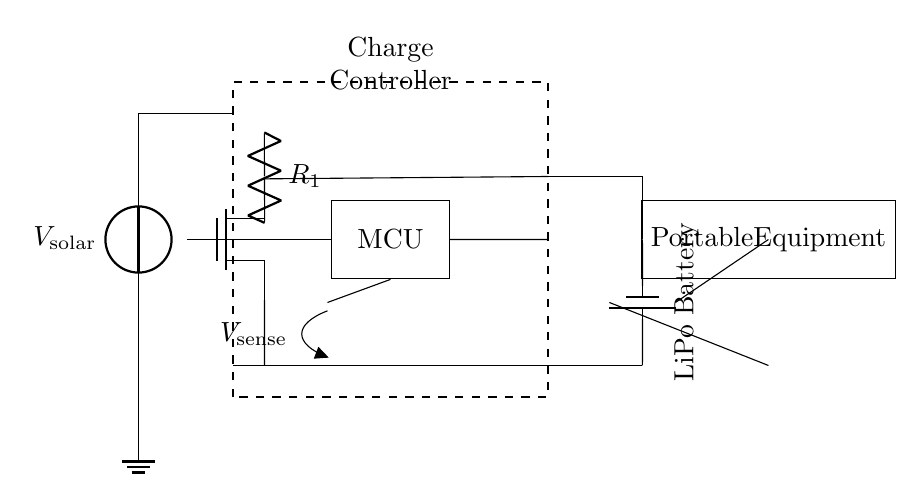What is the main purpose of the charge controller in this circuit? The charge controller regulates the voltage and current from the solar panel to the battery to prevent overcharging and ensure safe operation.
Answer: regulates voltage and current What type of battery is used in this circuit? The battery is a LiPo battery, indicated by the labeling next to the battery symbol in the circuit diagram.
Answer: LiPo Battery How many components are connected in series to the load? There are two components (the battery and load) connected in series; they share the same current path from the battery to the load.
Answer: Two What is the function of the resistor labeled R1? The resistor R1 is used to limit current to the gate of the MOSFET, thereby controlling its switching operation based on the signal from the microcontroller.
Answer: limit current Which component is responsible for sensing voltage in this circuit? The voltage sense is indicated by the open node labeled V-sense, which is connected to the microcontroller to monitor battery voltage.
Answer: Voltage Sensor What happens to the MOSFET when the microcontroller receives a signal? When the microcontroller sends a signal to the MOSFET's gate, it turns on, allowing current to flow from the solar panel to the battery/load.
Answer: Turns on Where does the solar energy input enter the circuit? The solar energy enters the circuit at the solar panel, represented by the voltage source at the top of the diagram.
Answer: Solar panel 